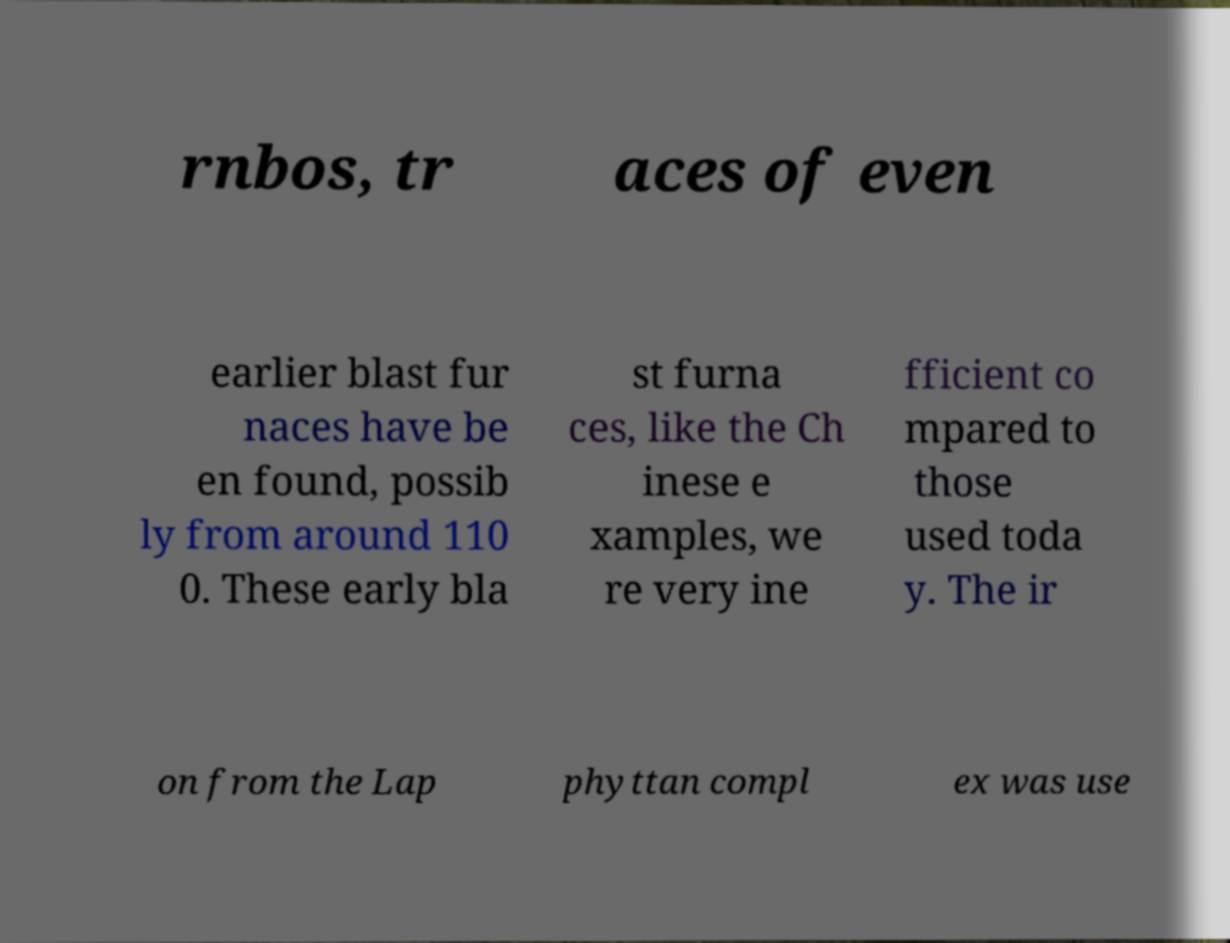For documentation purposes, I need the text within this image transcribed. Could you provide that? rnbos, tr aces of even earlier blast fur naces have be en found, possib ly from around 110 0. These early bla st furna ces, like the Ch inese e xamples, we re very ine fficient co mpared to those used toda y. The ir on from the Lap phyttan compl ex was use 